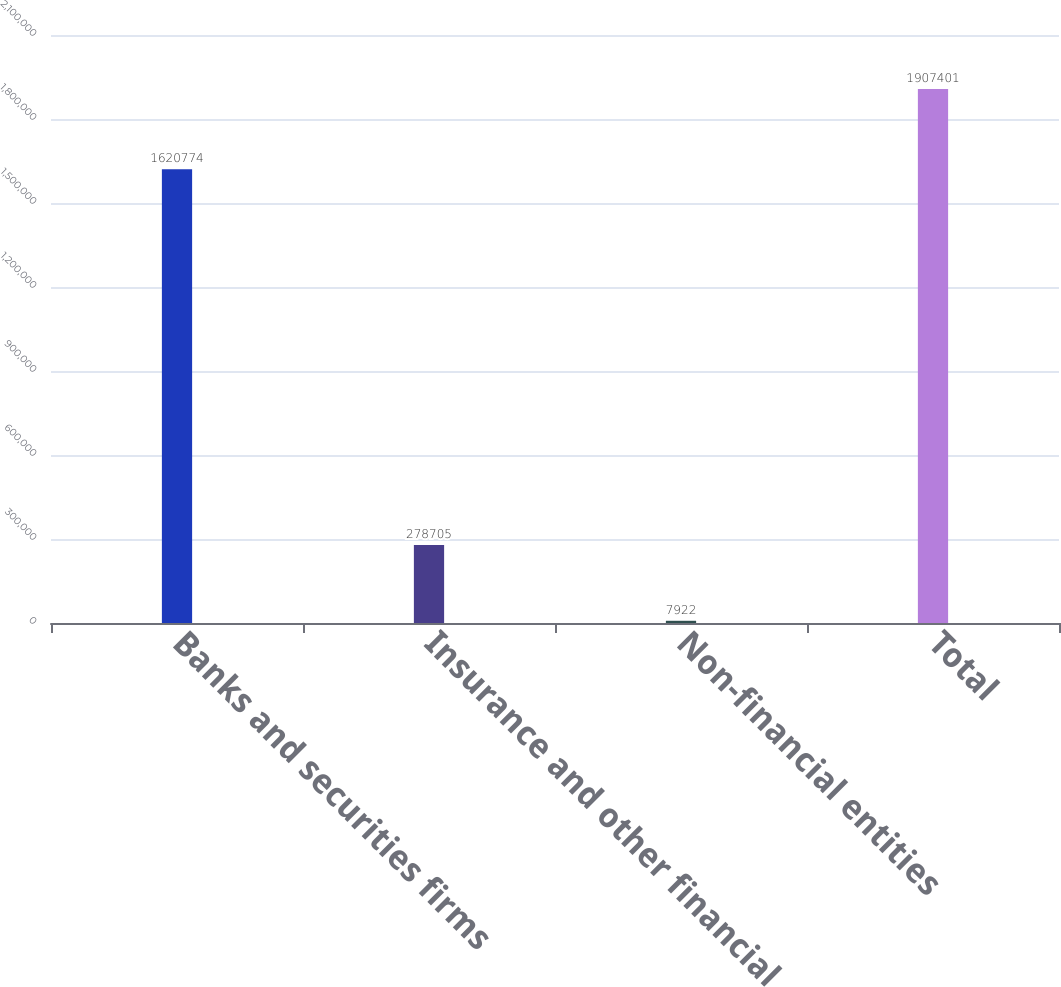Convert chart. <chart><loc_0><loc_0><loc_500><loc_500><bar_chart><fcel>Banks and securities firms<fcel>Insurance and other financial<fcel>Non-financial entities<fcel>Total<nl><fcel>1.62077e+06<fcel>278705<fcel>7922<fcel>1.9074e+06<nl></chart> 